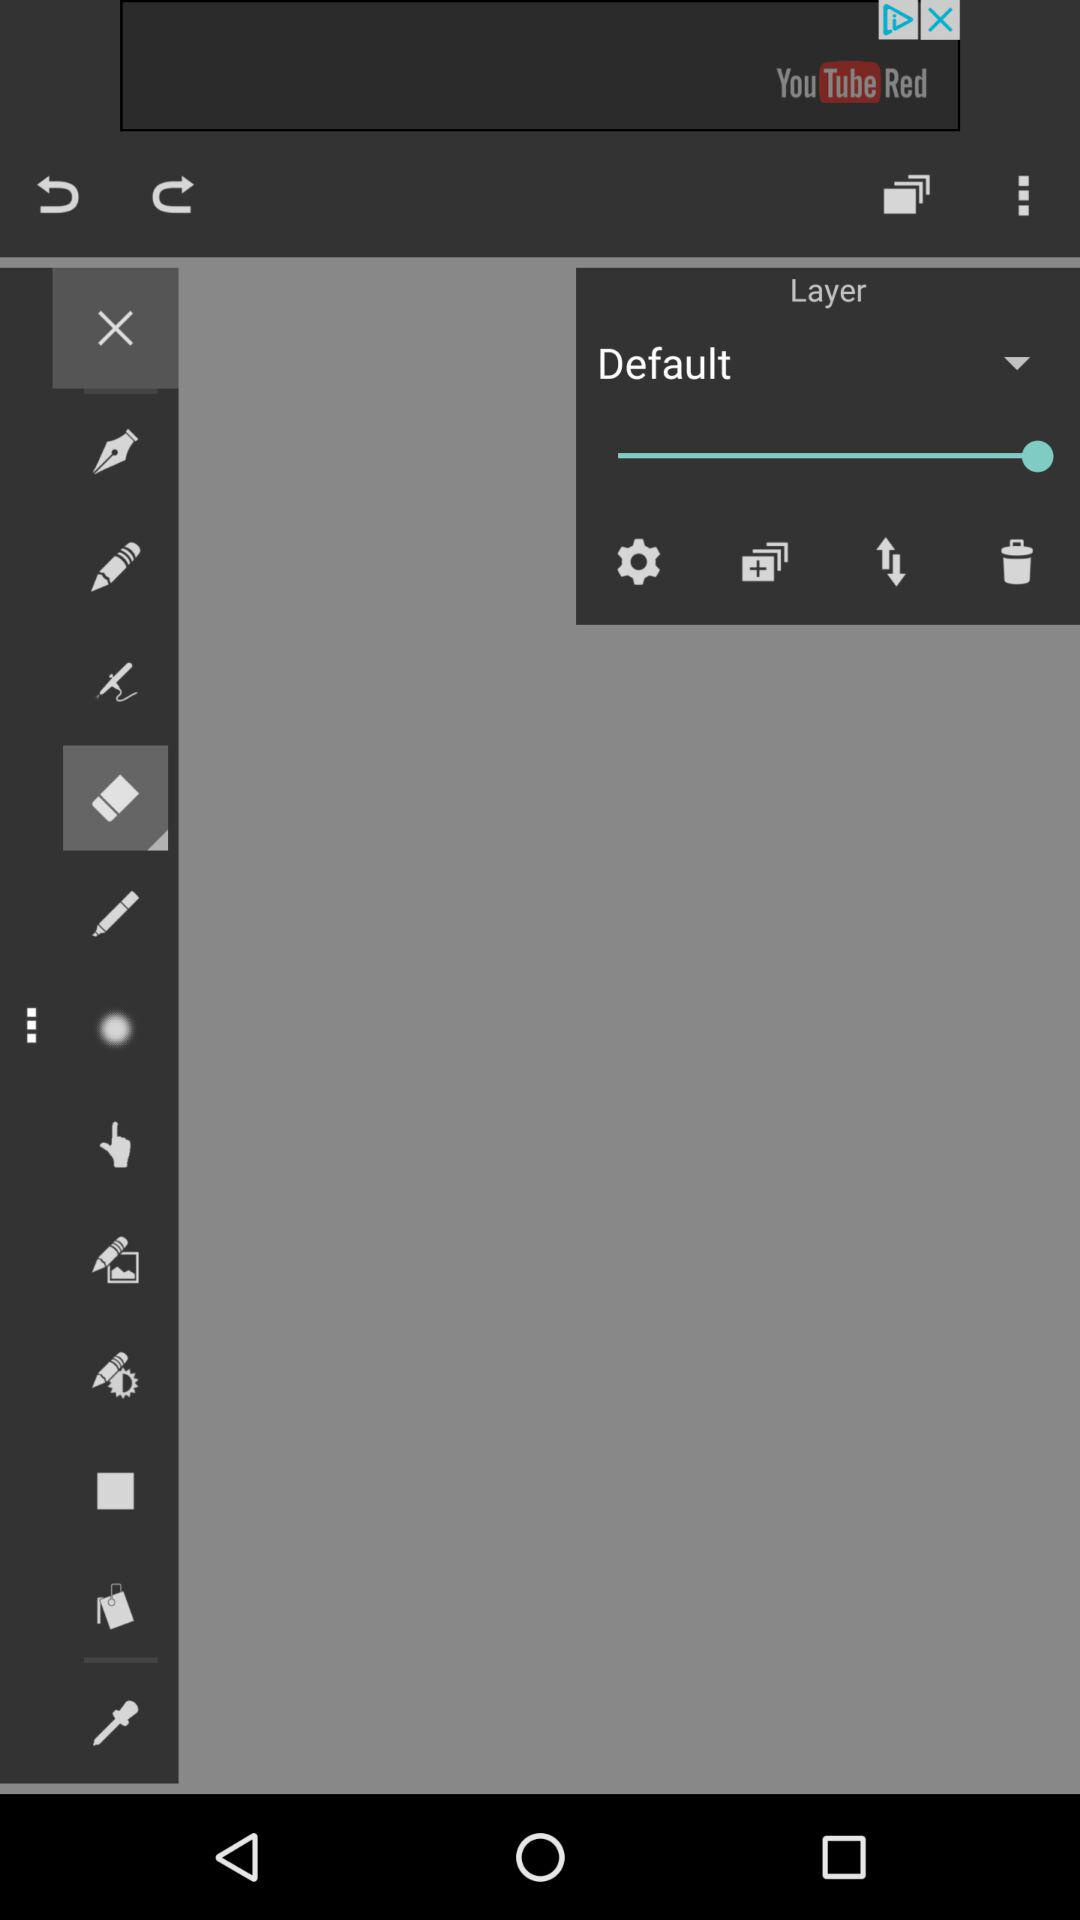What is the status of "Layer"? The status is "Default". 